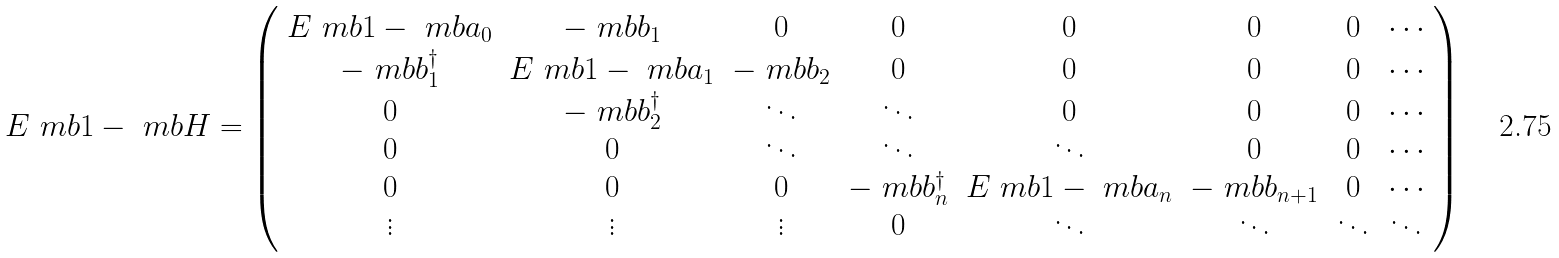<formula> <loc_0><loc_0><loc_500><loc_500>E \ m b { 1 } - \ m b { H } = \left ( \begin{array} { c c c c c c c c } E \ m b { 1 } - \ m b { a _ { 0 } } & - \ m b { b _ { 1 } } & 0 & 0 & 0 & 0 & 0 & \cdots \\ - \ m b { b ^ { \dagger } _ { 1 } } & E \ m b { 1 } - \ m b { a _ { 1 } } & - \ m b { b _ { 2 } } & 0 & 0 & 0 & 0 & \cdots \\ 0 & - \ m b { b ^ { \dagger } _ { 2 } } & \ddots & \ddots & 0 & 0 & 0 & \cdots \\ 0 & 0 & \ddots & \ddots & \ddots & 0 & 0 & \cdots \\ 0 & 0 & 0 & - \ m b { b ^ { \dagger } _ { n } } & E \ m b { 1 } - \ m b { a _ { n } } & - \ m b { b _ { n + 1 } } & 0 & \cdots \\ \vdots & \vdots & \vdots & 0 & \ddots & \ddots & \ddots & \ddots \end{array} \right )</formula> 